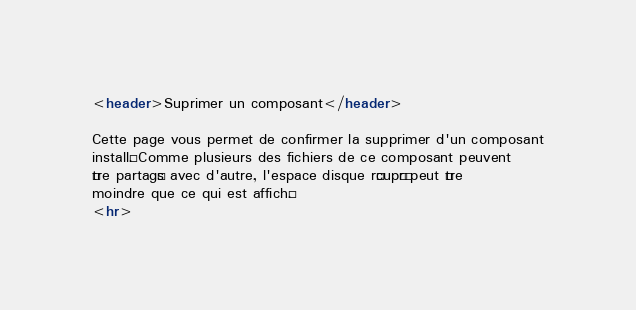<code> <loc_0><loc_0><loc_500><loc_500><_HTML_><header>Suprimer un composant</header>

Cette page vous permet de confirmer la supprimer d'un composant
installé. Comme plusieurs des fichiers de ce composant peuvent
être partagés avec d'autre, l'espace disque récupéré peut être
moindre que ce qui est affiché.
<hr>
</code> 